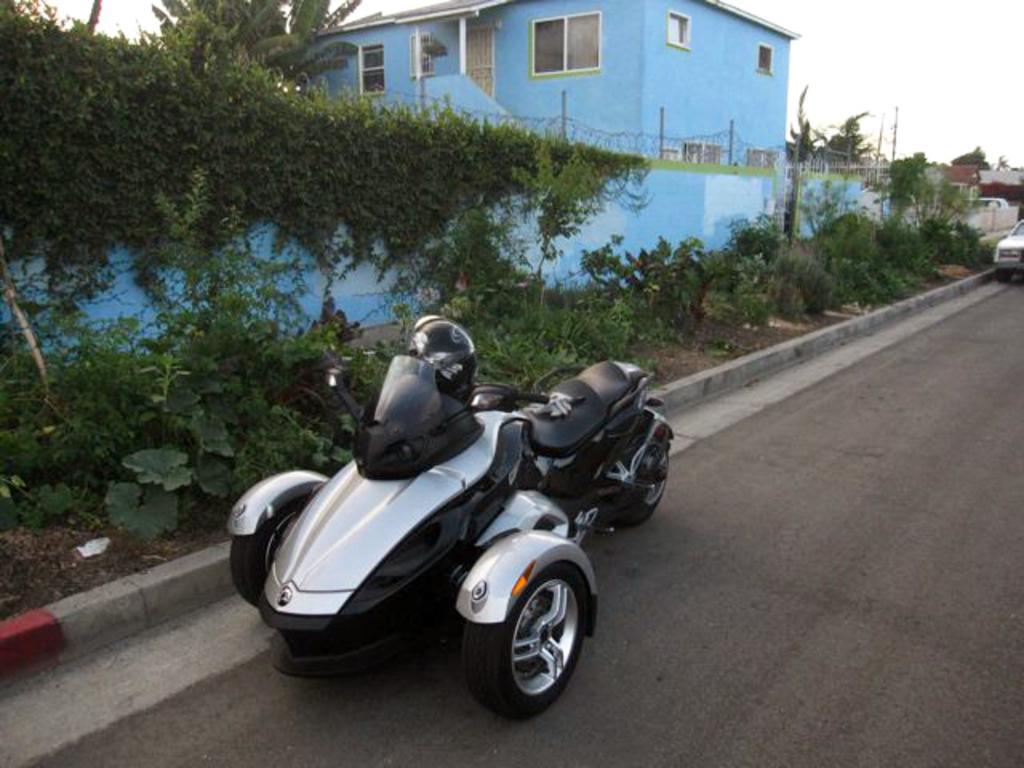Can you describe this image briefly? In this image I see 2 vehicles on the road and I see number of plants and I see the creepers on this wall. In the background I see the buildings and the trees and I see the sky. 